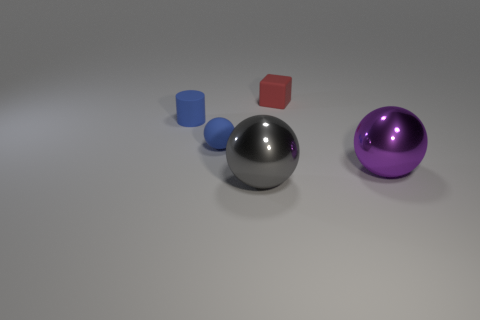Is there another big object of the same shape as the purple object?
Your answer should be very brief. Yes. There is a red rubber object that is the same size as the blue rubber ball; what is its shape?
Your answer should be compact. Cube. Is there a big metallic thing in front of the metallic ball that is on the right side of the big shiny ball that is on the left side of the big purple object?
Provide a succinct answer. Yes. Are there any purple things of the same size as the gray thing?
Make the answer very short. Yes. There is a blue cylinder to the left of the small rubber block; how big is it?
Keep it short and to the point. Small. There is a matte thing to the right of the big shiny ball that is in front of the sphere to the right of the large gray metal object; what color is it?
Offer a terse response. Red. What color is the matte cylinder that is left of the red block that is behind the tiny blue matte cylinder?
Keep it short and to the point. Blue. Is the number of tiny cylinders in front of the gray object greater than the number of tiny rubber things to the left of the purple object?
Your answer should be very brief. No. Is the red cube on the right side of the blue matte cylinder made of the same material as the big object that is right of the large gray metal sphere?
Your answer should be very brief. No. There is a red rubber thing; are there any big gray metallic spheres on the right side of it?
Offer a terse response. No. 